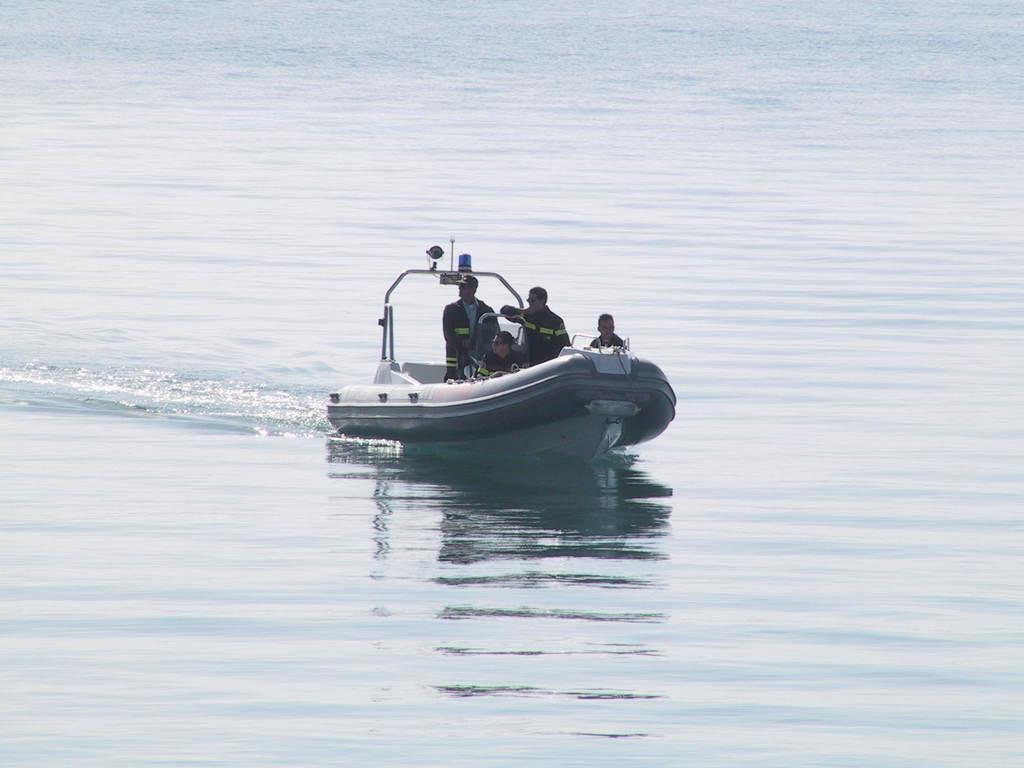Please provide a concise description of this image. In this picture I can see there is a boat in the lake and there are some people standing in the boat and this person is sitting. 